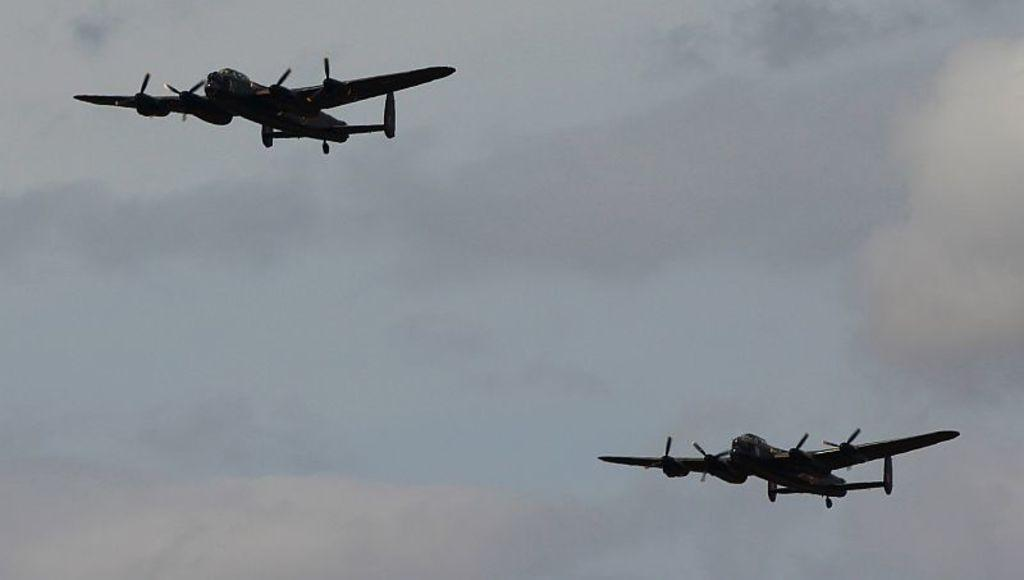How many airplanes are visible in the picture? There are two airplanes in the picture. What is the condition of the sky in the background? The sky in the background is cloudy. Can you tell me the direction the tiger is facing in the image? There is no tiger present in the image. Is the island visible in the picture? There is no island present in the image. 